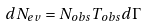<formula> <loc_0><loc_0><loc_500><loc_500>d N _ { e v } = N _ { o b s } T _ { o b s } d \Gamma</formula> 